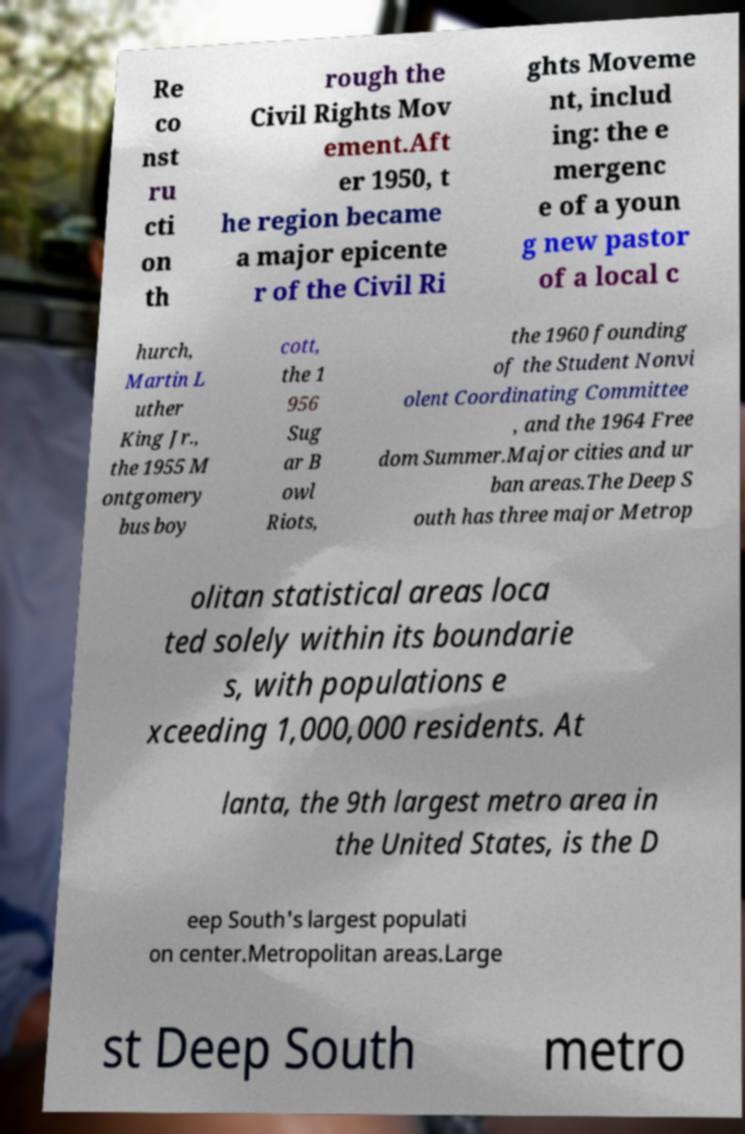Can you read and provide the text displayed in the image?This photo seems to have some interesting text. Can you extract and type it out for me? Re co nst ru cti on th rough the Civil Rights Mov ement.Aft er 1950, t he region became a major epicente r of the Civil Ri ghts Moveme nt, includ ing: the e mergenc e of a youn g new pastor of a local c hurch, Martin L uther King Jr., the 1955 M ontgomery bus boy cott, the 1 956 Sug ar B owl Riots, the 1960 founding of the Student Nonvi olent Coordinating Committee , and the 1964 Free dom Summer.Major cities and ur ban areas.The Deep S outh has three major Metrop olitan statistical areas loca ted solely within its boundarie s, with populations e xceeding 1,000,000 residents. At lanta, the 9th largest metro area in the United States, is the D eep South's largest populati on center.Metropolitan areas.Large st Deep South metro 